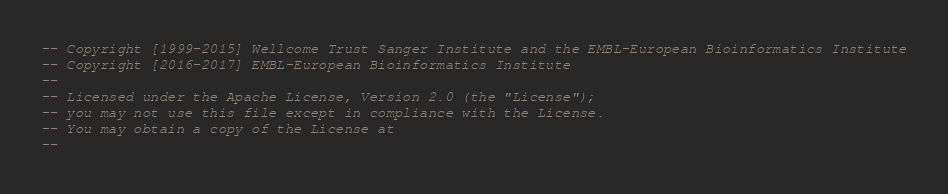Convert code to text. <code><loc_0><loc_0><loc_500><loc_500><_SQL_>-- Copyright [1999-2015] Wellcome Trust Sanger Institute and the EMBL-European Bioinformatics Institute
-- Copyright [2016-2017] EMBL-European Bioinformatics Institute
-- 
-- Licensed under the Apache License, Version 2.0 (the "License");
-- you may not use this file except in compliance with the License.
-- You may obtain a copy of the License at
-- </code> 